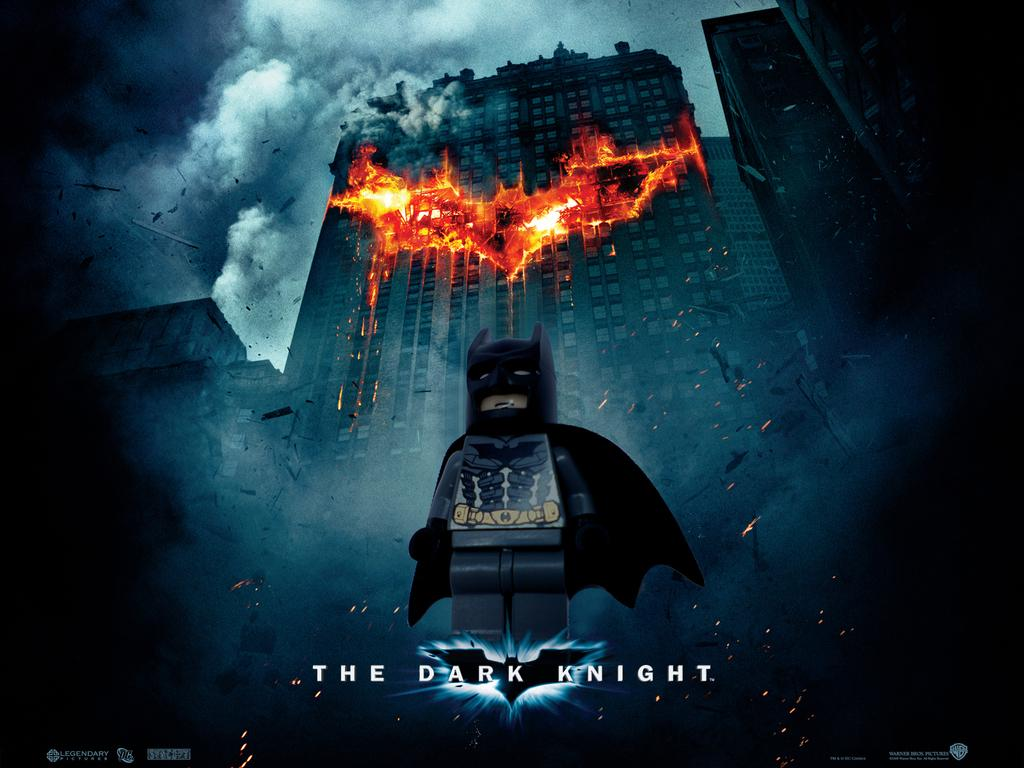<image>
Relay a brief, clear account of the picture shown. Lego batman appears above the words, "The Dark Knight." 